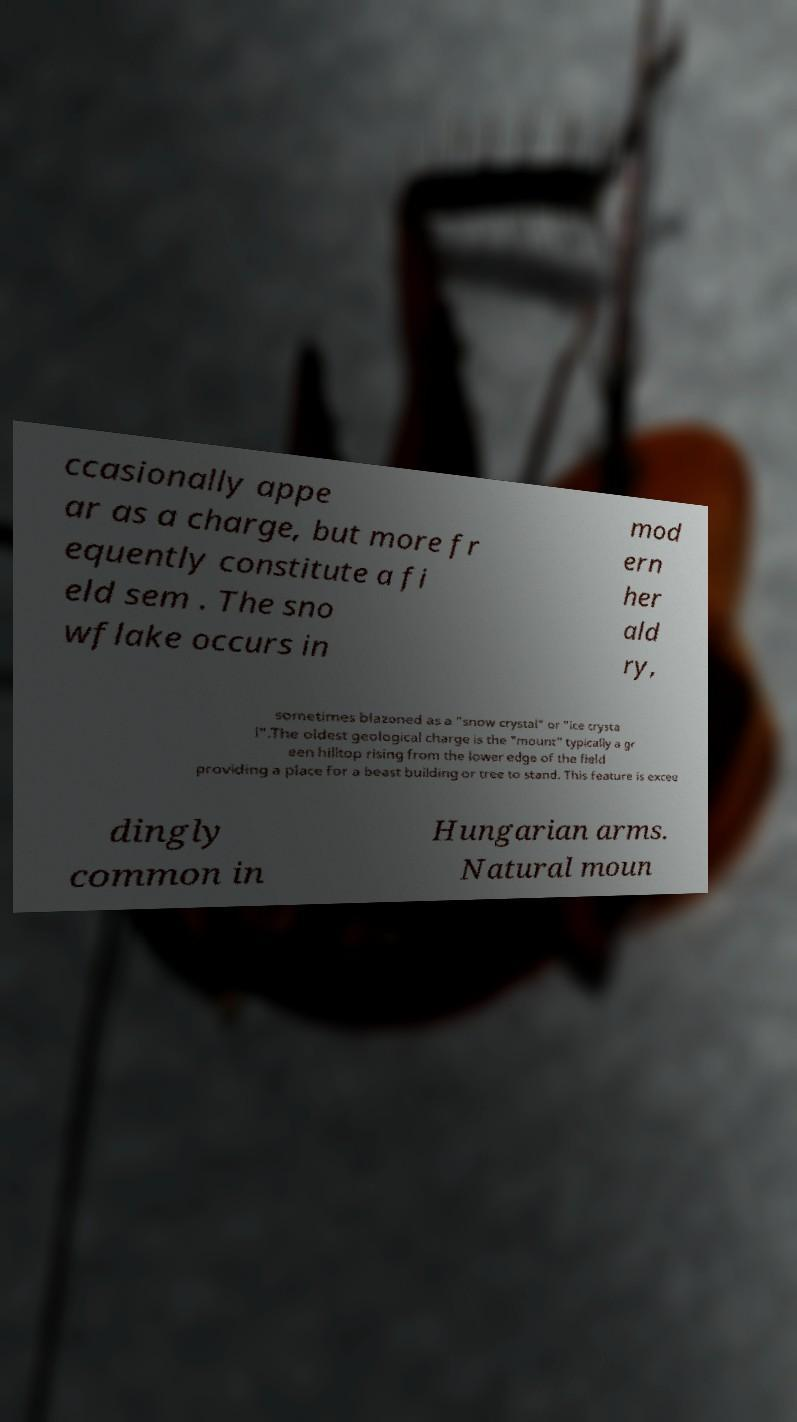For documentation purposes, I need the text within this image transcribed. Could you provide that? ccasionally appe ar as a charge, but more fr equently constitute a fi eld sem . The sno wflake occurs in mod ern her ald ry, sometimes blazoned as a "snow crystal" or "ice crysta l".The oldest geological charge is the "mount" typically a gr een hilltop rising from the lower edge of the field providing a place for a beast building or tree to stand. This feature is excee dingly common in Hungarian arms. Natural moun 